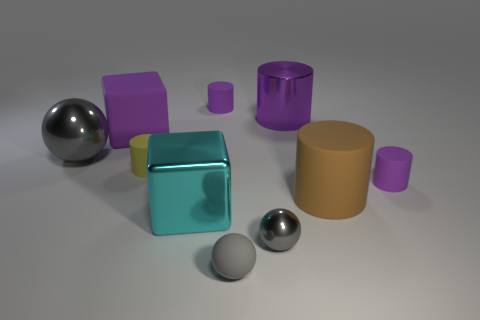What size is the metal sphere in front of the sphere that is to the left of the tiny purple rubber object that is left of the large purple cylinder?
Ensure brevity in your answer.  Small. Is the shape of the small yellow matte thing the same as the small gray matte thing?
Your answer should be very brief. No. How big is the purple thing that is in front of the shiny cylinder and on the left side of the brown rubber cylinder?
Offer a terse response. Large. There is another large object that is the same shape as the big brown thing; what material is it?
Your answer should be very brief. Metal. There is a gray thing that is on the left side of the rubber cylinder that is behind the yellow cylinder; what is its material?
Your answer should be compact. Metal. There is a large brown rubber thing; does it have the same shape as the purple matte object that is in front of the yellow object?
Your answer should be compact. Yes. How many rubber things are big brown things or gray objects?
Your answer should be compact. 2. What color is the tiny rubber object behind the purple matte thing left of the purple matte cylinder left of the brown thing?
Offer a terse response. Purple. How many other things are there of the same material as the big purple cylinder?
Keep it short and to the point. 3. Do the big matte thing that is to the right of the yellow matte cylinder and the purple metal thing have the same shape?
Your answer should be compact. Yes. 